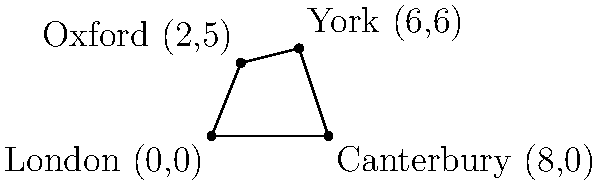During the English Reformation, four key events occurred in different cities: London (0,0), Canterbury (8,0), York (6,6), and Oxford (2,5). These coordinates represent their positions on a map (in arbitrary units). Calculate the area of the quadrilateral formed by connecting these locations. Round your answer to the nearest whole number. To find the area of this quadrilateral, we can use the Shoelace formula (also known as the surveyor's formula). The steps are as follows:

1) The Shoelace formula for a quadrilateral with vertices $(x_1,y_1)$, $(x_2,y_2)$, $(x_3,y_3)$, and $(x_4,y_4)$ is:

   Area = $\frac{1}{2}|(x_1y_2 + x_2y_3 + x_3y_4 + x_4y_1) - (y_1x_2 + y_2x_3 + y_3x_4 + y_4x_1)|$

2) Substituting our coordinates:
   London (0,0), Canterbury (8,0), York (6,6), Oxford (2,5)

3) Applying the formula:

   Area = $\frac{1}{2}|((0 \cdot 0) + (8 \cdot 6) + (6 \cdot 5) + (2 \cdot 0)) - ((0 \cdot 8) + (0 \cdot 6) + (6 \cdot 2) + (5 \cdot 0))|$

4) Simplifying:

   Area = $\frac{1}{2}|(0 + 48 + 30 + 0) - (0 + 0 + 12 + 0)|$
   
   Area = $\frac{1}{2}|78 - 12|$
   
   Area = $\frac{1}{2}(66)$
   
   Area = 33

5) The question asks to round to the nearest whole number, but 33 is already a whole number.

Therefore, the area of the quadrilateral is 33 square units.
Answer: 33 square units 